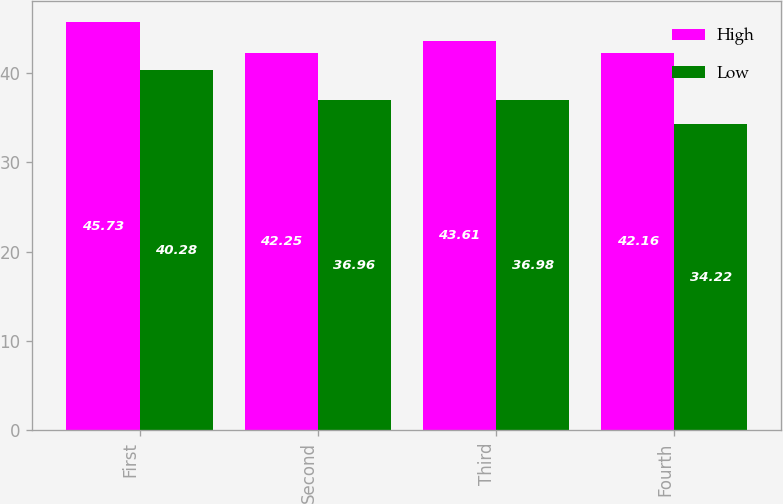Convert chart to OTSL. <chart><loc_0><loc_0><loc_500><loc_500><stacked_bar_chart><ecel><fcel>First<fcel>Second<fcel>Third<fcel>Fourth<nl><fcel>High<fcel>45.73<fcel>42.25<fcel>43.61<fcel>42.16<nl><fcel>Low<fcel>40.28<fcel>36.96<fcel>36.98<fcel>34.22<nl></chart> 